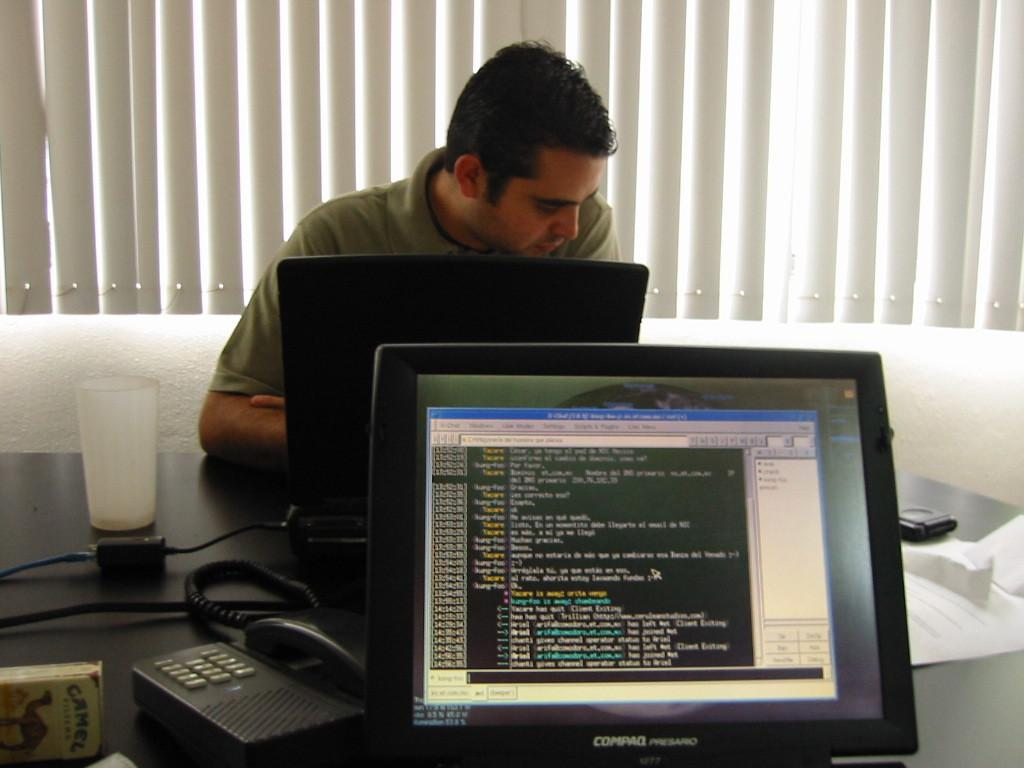<image>
Summarize the visual content of the image. guy using a computer and another compaq presario computer that has app open but no one at it 